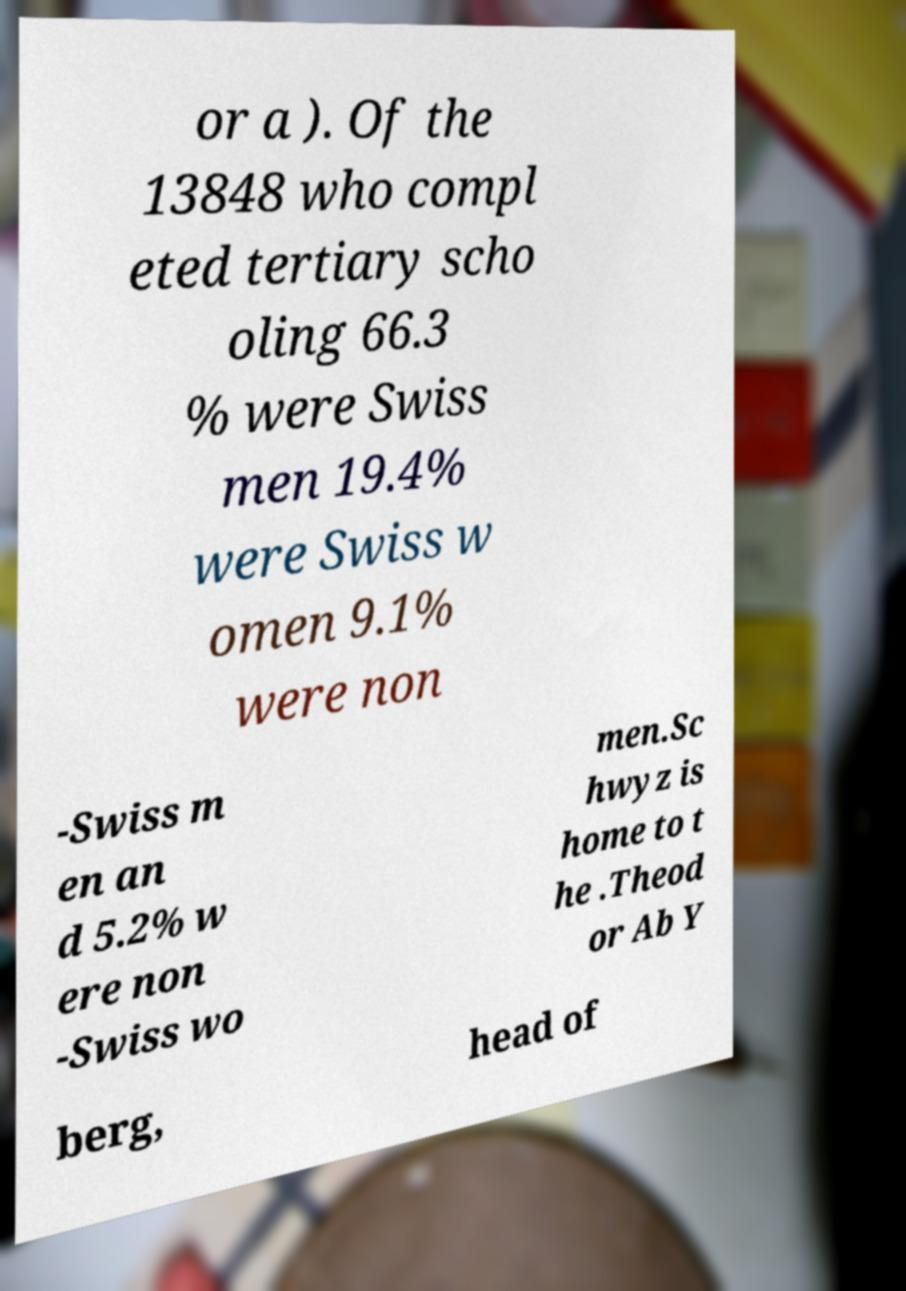I need the written content from this picture converted into text. Can you do that? or a ). Of the 13848 who compl eted tertiary scho oling 66.3 % were Swiss men 19.4% were Swiss w omen 9.1% were non -Swiss m en an d 5.2% w ere non -Swiss wo men.Sc hwyz is home to t he .Theod or Ab Y berg, head of 